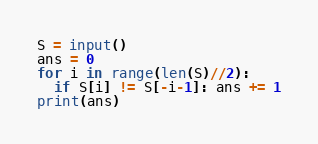<code> <loc_0><loc_0><loc_500><loc_500><_Python_>S = input()
ans = 0
for i in range(len(S)//2):
  if S[i] != S[-i-1]: ans += 1
print(ans)</code> 